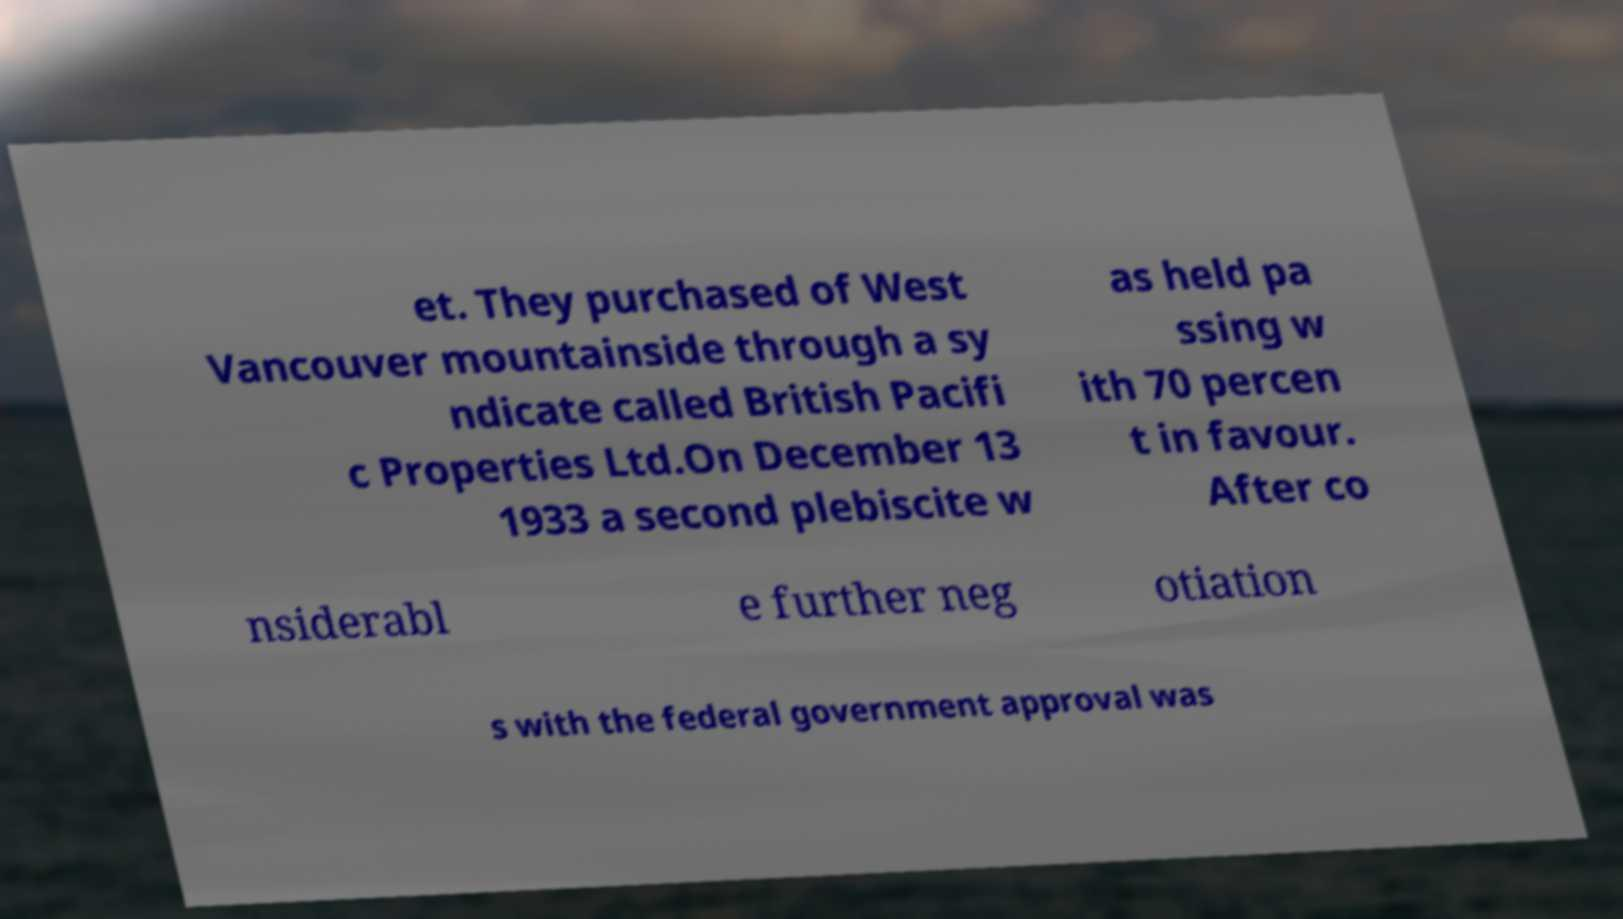Could you extract and type out the text from this image? et. They purchased of West Vancouver mountainside through a sy ndicate called British Pacifi c Properties Ltd.On December 13 1933 a second plebiscite w as held pa ssing w ith 70 percen t in favour. After co nsiderabl e further neg otiation s with the federal government approval was 